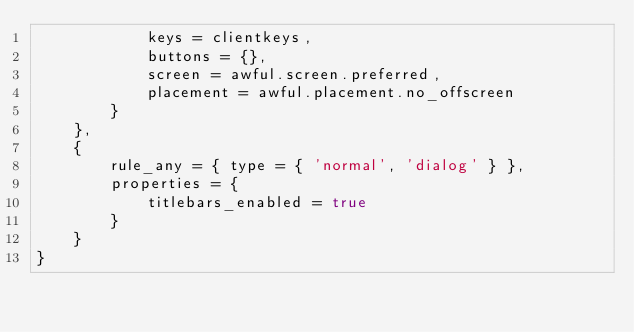<code> <loc_0><loc_0><loc_500><loc_500><_Lua_>            keys = clientkeys,
            buttons = {},
            screen = awful.screen.preferred,
            placement = awful.placement.no_offscreen
        }
    },
    {
        rule_any = { type = { 'normal', 'dialog' } },
        properties = {
            titlebars_enabled = true
        }
    }
}
</code> 